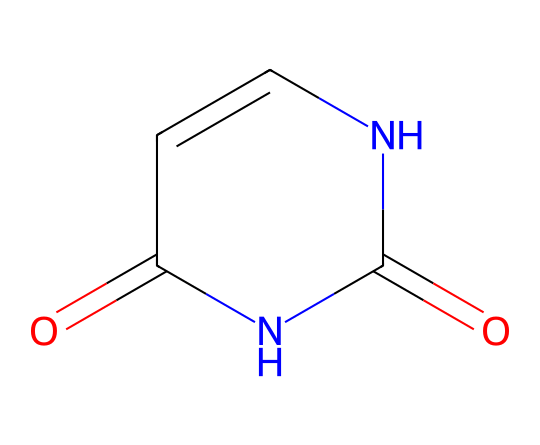What is the empirical formula of maleic hydrazide? To find the empirical formula, we identify the elements within the SMILES representation and count their occurrences. Maleic hydrazide contains carbon (C), hydrogen (H), nitrogen (N), and oxygen (O). Counting these, we have: 4 carbon atoms, 6 hydrogen atoms, 4 nitrogen atoms, and 2 oxygen atoms. Therefore, the empirical formula is C4H6N4O2.
Answer: C4H6N4O2 How many nitrogen atoms are present in this molecule? Analyzing the SMILES representation, we identify two functional groups with nitrogen atoms. They appear in the hydrazine moiety (the part of the structure that includes N). Counting them gives us a total of 2 nitrogen atoms.
Answer: 2 What type of chemical bond connects the nitrogen atoms in maleic hydrazide? The nitrogen atoms in the structure are involved in forming amide and hydrazone linkages. This is characterized by double bonds to nitrogen atoms related to the hydrazone functionality, which involves bonding between nitrogen and carbon. Specifically, they represent covalent bonds.
Answer: covalent Which functional groups are present in maleic hydrazide? By inspecting the SMILES representation, we can see the presence of an amide (due to the carbonyl and nitrogen connection) and a double bond between carbon and nitrogen indicative of a hydrazone. This is typical for maleic hydrazide, confirming the functional groups involved.
Answer: amide and hydrazone Is maleic hydrazide a solid, liquid, or gas at room temperature? The physical state of a substance at room temperature can be identified via its typical use or chemical properties. Maleic hydrazide is commonly used as a plant growth regulator and has been characterized in literature as a solid at room temperature.
Answer: solid How many rings are in the structure of maleic hydrazide? Analyzing the SMILES structure, we see that the representation includes a cyclic structure indicated by the '1' in the notation, which confines the atoms in a ring. This confirms there is one ring present in the molecule.
Answer: 1 